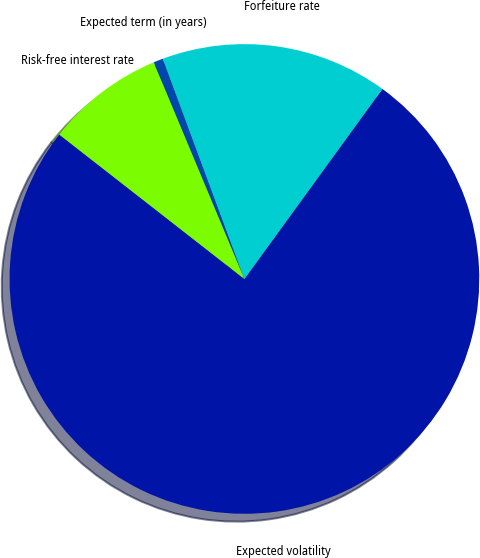<chart> <loc_0><loc_0><loc_500><loc_500><pie_chart><fcel>Expected volatility<fcel>Risk-free interest rate<fcel>Expected term (in years)<fcel>Forfeiture rate<nl><fcel>75.55%<fcel>8.15%<fcel>0.66%<fcel>15.64%<nl></chart> 